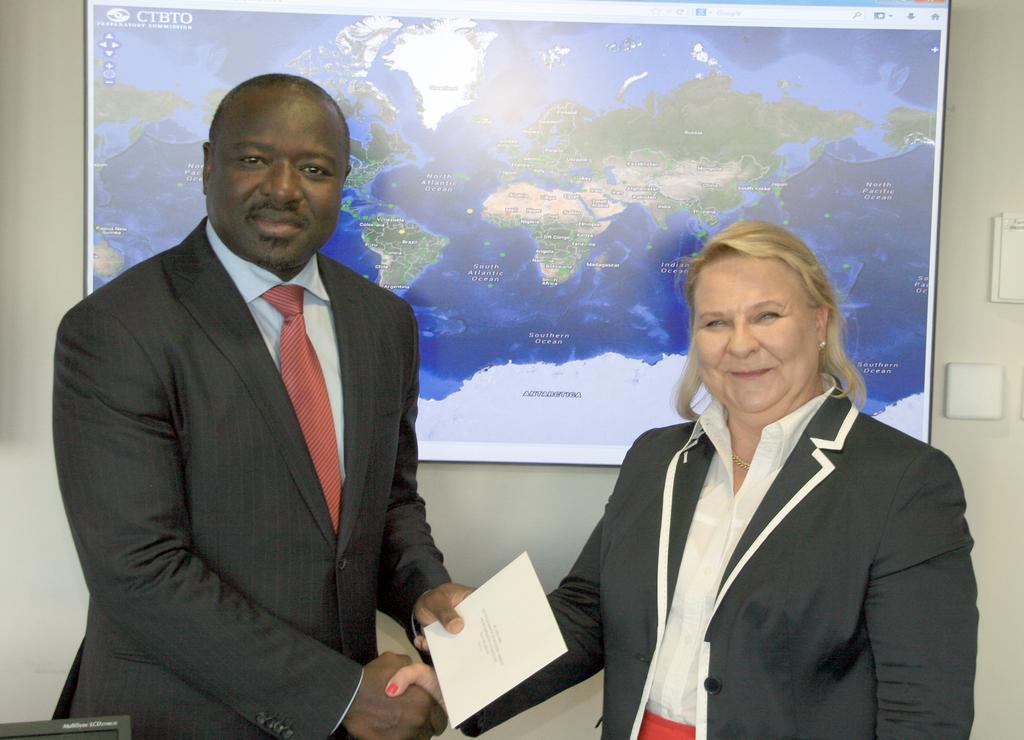Could you give a brief overview of what you see in this image? In the image we can see there are people standing and they are shaking hands. Behind there is a map. 